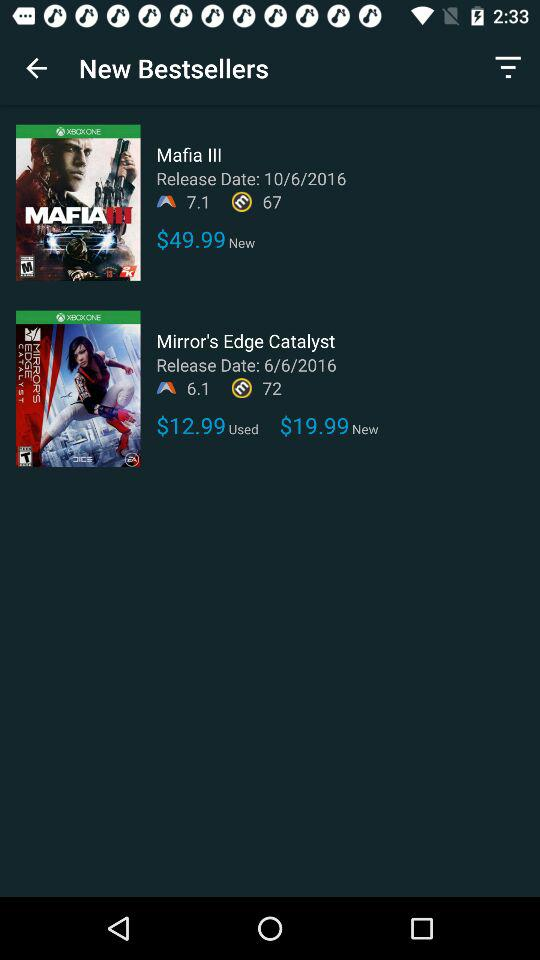What is the price of the new "Mirror's Edge Catalyst" game? The price of the new "Mirror's Edge Catalyst" game is $19.99. 